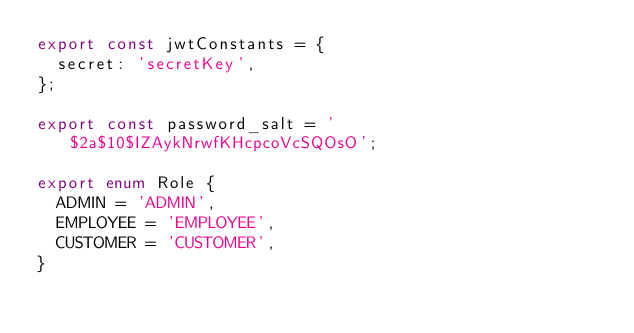Convert code to text. <code><loc_0><loc_0><loc_500><loc_500><_TypeScript_>export const jwtConstants = {
  secret: 'secretKey',
};

export const password_salt = '$2a$10$IZAykNrwfKHcpcoVcSQOsO';

export enum Role {
  ADMIN = 'ADMIN',
  EMPLOYEE = 'EMPLOYEE',
  CUSTOMER = 'CUSTOMER',
}
</code> 